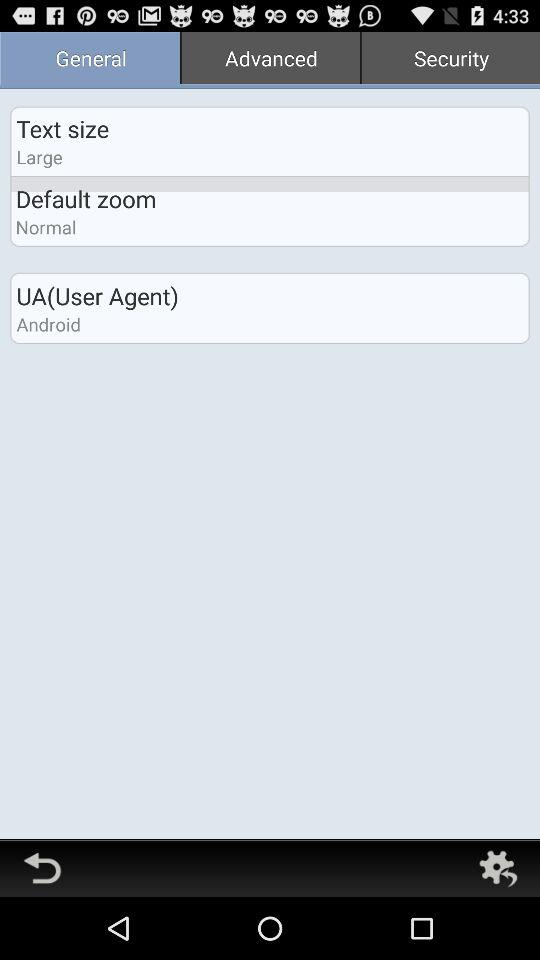What is the selected tab? The selected tab is "General". 